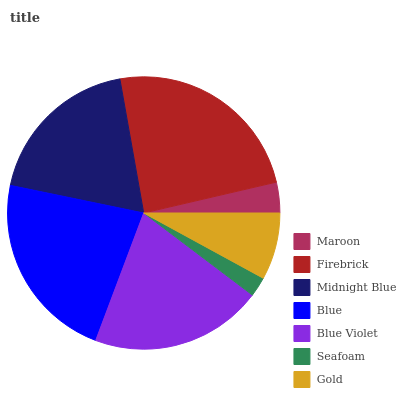Is Seafoam the minimum?
Answer yes or no. Yes. Is Firebrick the maximum?
Answer yes or no. Yes. Is Midnight Blue the minimum?
Answer yes or no. No. Is Midnight Blue the maximum?
Answer yes or no. No. Is Firebrick greater than Midnight Blue?
Answer yes or no. Yes. Is Midnight Blue less than Firebrick?
Answer yes or no. Yes. Is Midnight Blue greater than Firebrick?
Answer yes or no. No. Is Firebrick less than Midnight Blue?
Answer yes or no. No. Is Midnight Blue the high median?
Answer yes or no. Yes. Is Midnight Blue the low median?
Answer yes or no. Yes. Is Maroon the high median?
Answer yes or no. No. Is Firebrick the low median?
Answer yes or no. No. 